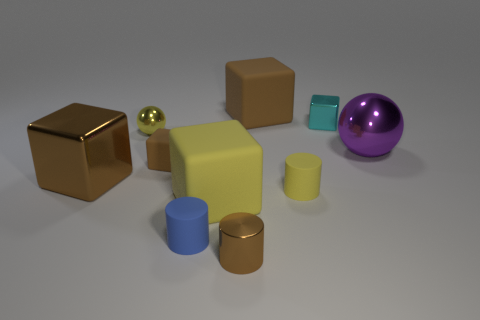Subtract all brown blocks. How many were subtracted if there are1brown blocks left? 2 Subtract all cyan spheres. How many brown cubes are left? 3 Subtract all cyan blocks. How many blocks are left? 4 Subtract all tiny cyan cubes. How many cubes are left? 4 Subtract all purple cubes. Subtract all green spheres. How many cubes are left? 5 Subtract all cylinders. How many objects are left? 7 Add 3 small metallic spheres. How many small metallic spheres are left? 4 Add 6 purple metal things. How many purple metal things exist? 7 Subtract 1 cyan blocks. How many objects are left? 9 Subtract all brown metallic cylinders. Subtract all purple metal spheres. How many objects are left? 8 